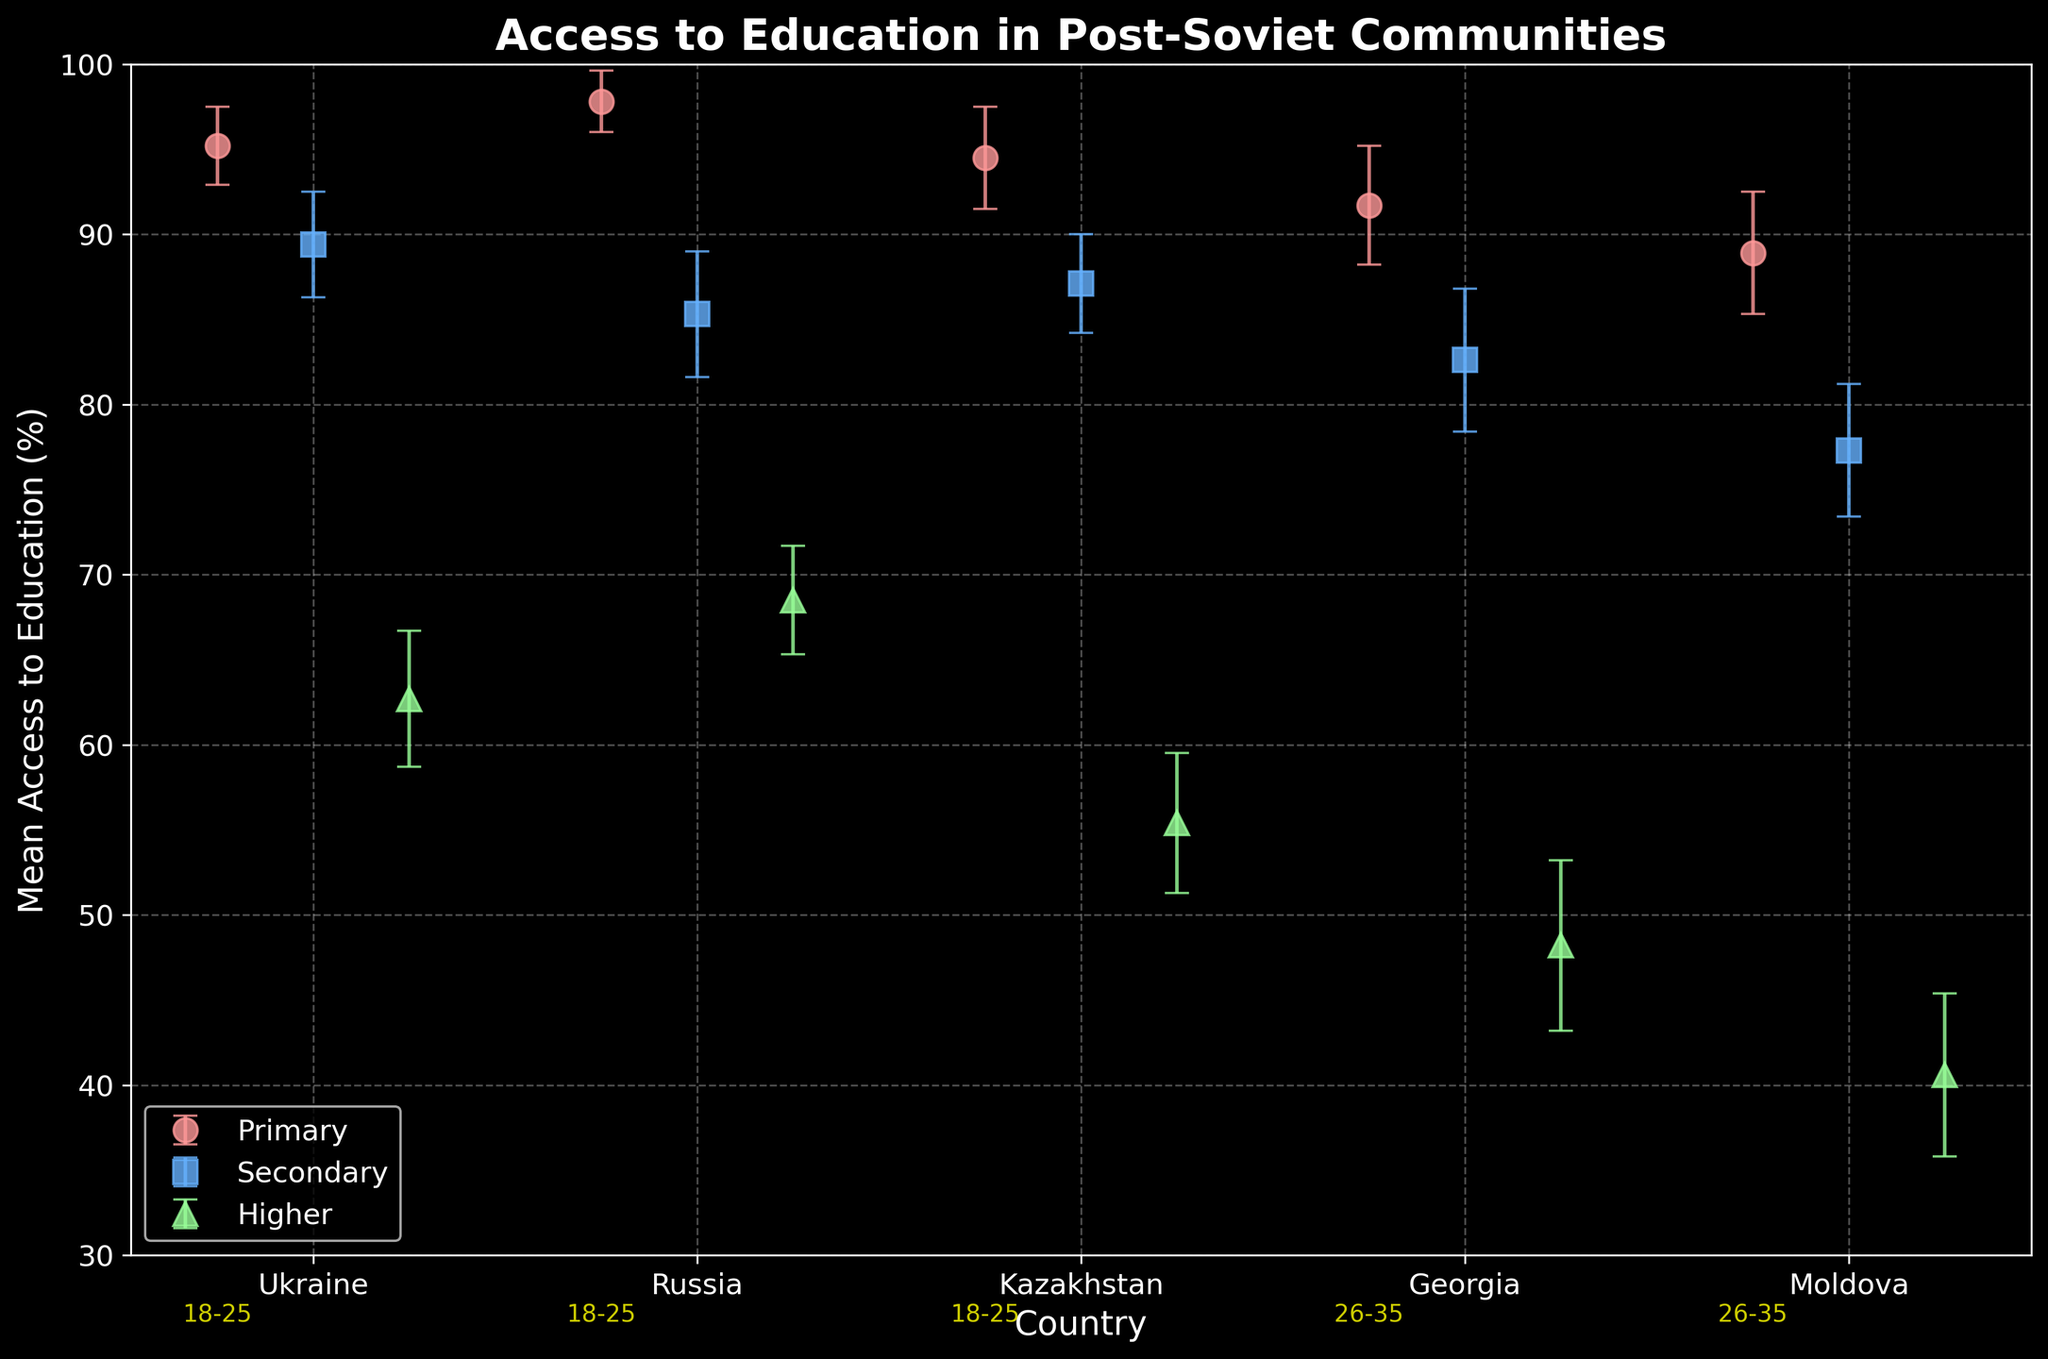What's the title of the plot? The title is located at the top of the plot. It reads, "Access to Education in Post-Soviet Communities".
Answer: Access to Education in Post-Soviet Communities Which country has the highest mean access to primary education? To determine this, refer to the data points labeled as "Primary" on the plot. The country with the highest mean access will be the one with the dot at the highest y-axis value for "Primary". It is Russia.
Answer: Russia Among the countries, which has the lowest mean access to higher education? Look at the data points labeled as "Higher" and find the lowest value on the y-axis. The country corresponding to this value is Moldova.
Answer: Moldova What is the range of mean access to secondary education for ages 18-25 in Ukraine? Identify the three age groups and their corresponding markers. For ages 18-25 in Ukraine, the secondary education access is represented by one point with an error bar that goes from approximately 86.3% to 92.5%. Therefore, the range is from approximately 86.3% to 92.5%.
Answer: 86.3% to 92.5% What is the difference in mean access to higher education between Russia and Moldova? Find the data points for higher education of both Russia and Moldova. Russia's mean access is 68.5%, while Moldova's is 40.6%. The difference is 68.5% - 40.6% = 27.9%.
Answer: 27.9% Which age group in Kazakhstan has access data labeled in the plot? The age group labels are annotated near the x-axis, closer to the 30% mark. For Kazakhstan, the labeled age group is 36-45.
Answer: 36-45 Compare the mean access to secondary education between Ukraine and Georgia. Which has a higher value and by how much? Look at the data points for secondary education in Ukraine and Georgia. Ukraine's value is 89.4%, and Georgia's is 82.6%. The difference (89.4% - 82.6%) is 6.8%, with Ukraine having the higher value.
Answer: Ukraine by 6.8% Describe the trend in access to higher education as the age group increases. To identify the trend, observe how the data points for "Higher" change across the different age groups in the plot. The mean access decreases as the age group increases, indicating a downward trend in access to higher education with aging.
Answer: Decreasing trend What is the average mean access to primary education across all countries in the plot? Calculate the mean access to primary education for each country and then find the average of these values: (95.2% + 97.8% + 94.5% + 91.7% + 88.9%) / 5 = 93.62%.
Answer: 93.62% 